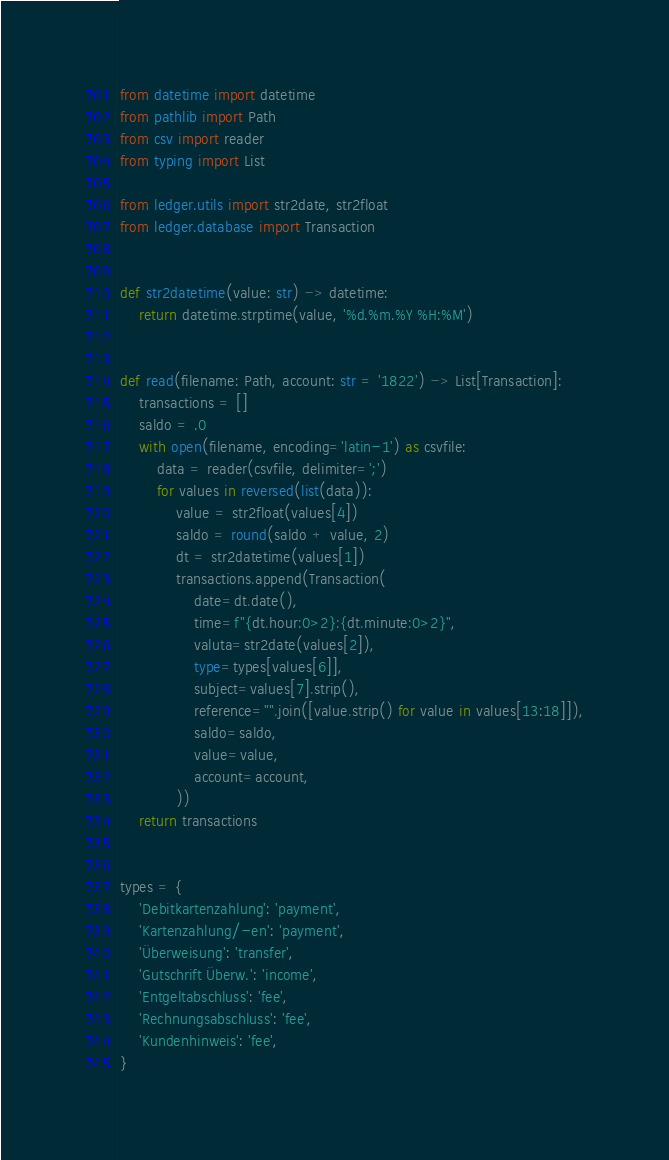Convert code to text. <code><loc_0><loc_0><loc_500><loc_500><_Python_>from datetime import datetime
from pathlib import Path
from csv import reader
from typing import List

from ledger.utils import str2date, str2float
from ledger.database import Transaction


def str2datetime(value: str) -> datetime:
    return datetime.strptime(value, '%d.%m.%Y %H:%M')


def read(filename: Path, account: str = '1822') -> List[Transaction]:
    transactions = []
    saldo = .0
    with open(filename, encoding='latin-1') as csvfile:
        data = reader(csvfile, delimiter=';')
        for values in reversed(list(data)):
            value = str2float(values[4])
            saldo = round(saldo + value, 2)
            dt = str2datetime(values[1])
            transactions.append(Transaction(
                date=dt.date(),
                time=f"{dt.hour:0>2}:{dt.minute:0>2}",
                valuta=str2date(values[2]),
                type=types[values[6]],
                subject=values[7].strip(),
                reference="".join([value.strip() for value in values[13:18]]),
                saldo=saldo,
                value=value,
                account=account,
            ))
    return transactions


types = {
    'Debitkartenzahlung': 'payment',
    'Kartenzahlung/-en': 'payment',
    'Überweisung': 'transfer',
    'Gutschrift Überw.': 'income',
    'Entgeltabschluss': 'fee',
    'Rechnungsabschluss': 'fee',
    'Kundenhinweis': 'fee',
}
</code> 